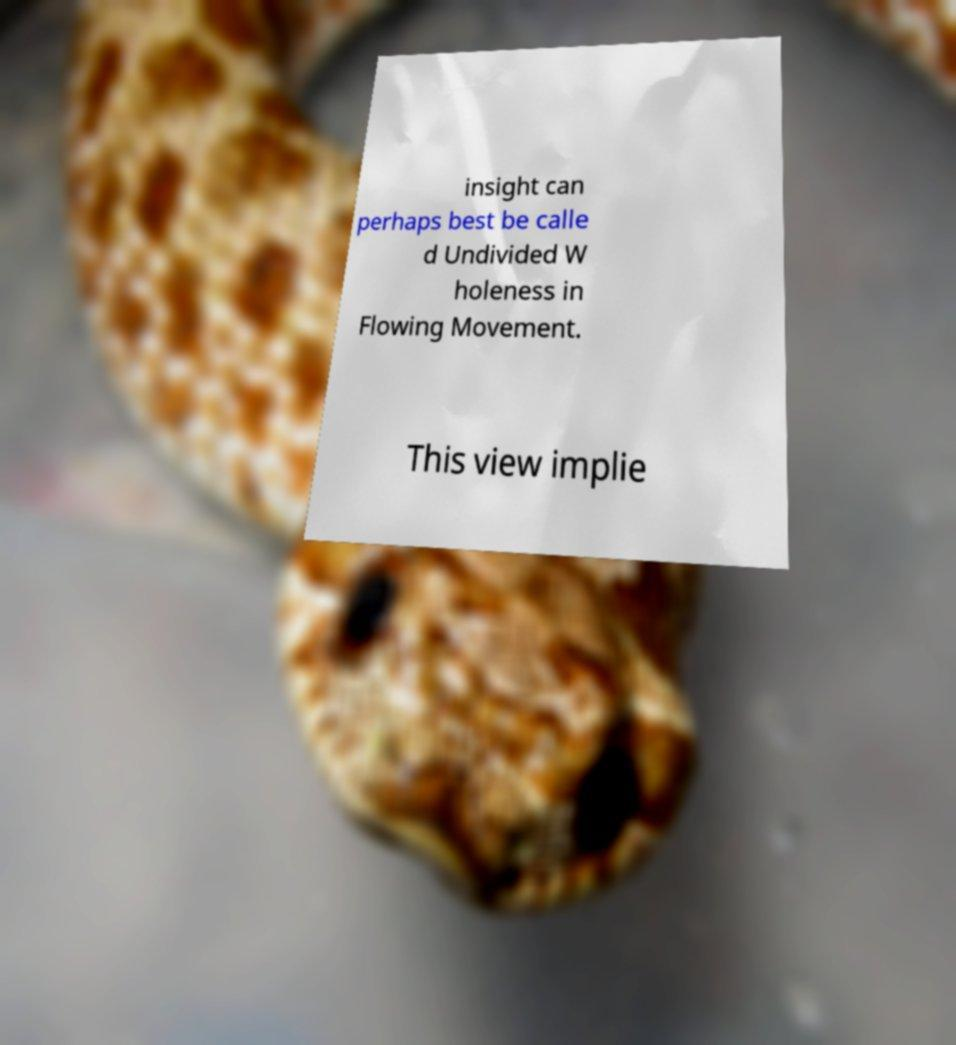For documentation purposes, I need the text within this image transcribed. Could you provide that? insight can perhaps best be calle d Undivided W holeness in Flowing Movement. This view implie 